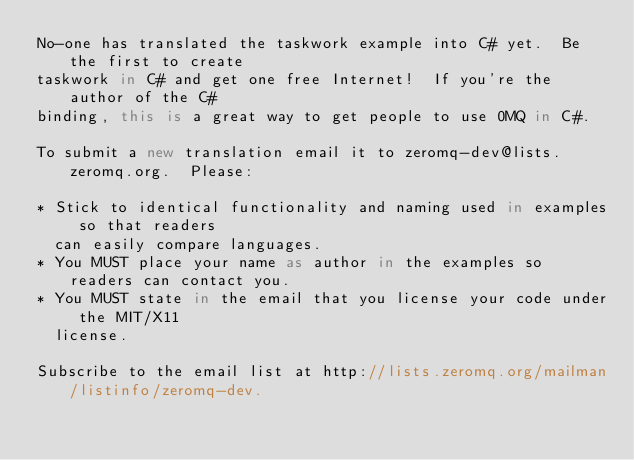Convert code to text. <code><loc_0><loc_0><loc_500><loc_500><_C#_>No-one has translated the taskwork example into C# yet.  Be the first to create
taskwork in C# and get one free Internet!  If you're the author of the C#
binding, this is a great way to get people to use 0MQ in C#.

To submit a new translation email it to zeromq-dev@lists.zeromq.org.  Please:

* Stick to identical functionality and naming used in examples so that readers
  can easily compare languages.
* You MUST place your name as author in the examples so readers can contact you.
* You MUST state in the email that you license your code under the MIT/X11
  license.

Subscribe to the email list at http://lists.zeromq.org/mailman/listinfo/zeromq-dev.
</code> 